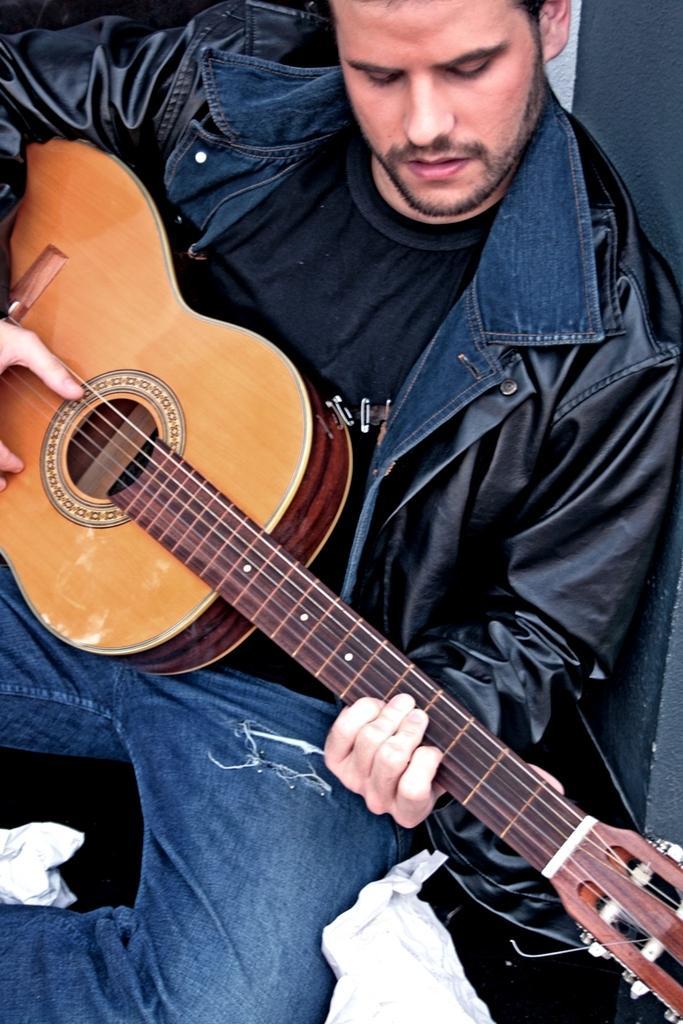Describe this image in one or two sentences. There is a man sitting on the floor while playing the guitar which is in his hands. 